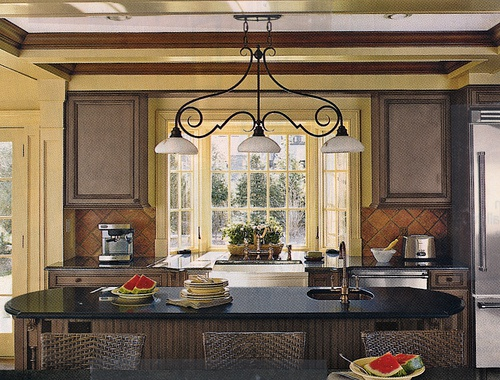Describe the objects in this image and their specific colors. I can see refrigerator in tan, black, darkgray, gray, and lightgray tones, dining table in tan, black, brown, and gray tones, chair in tan, black, and gray tones, chair in tan, black, gray, and maroon tones, and chair in tan, gray, and black tones in this image. 